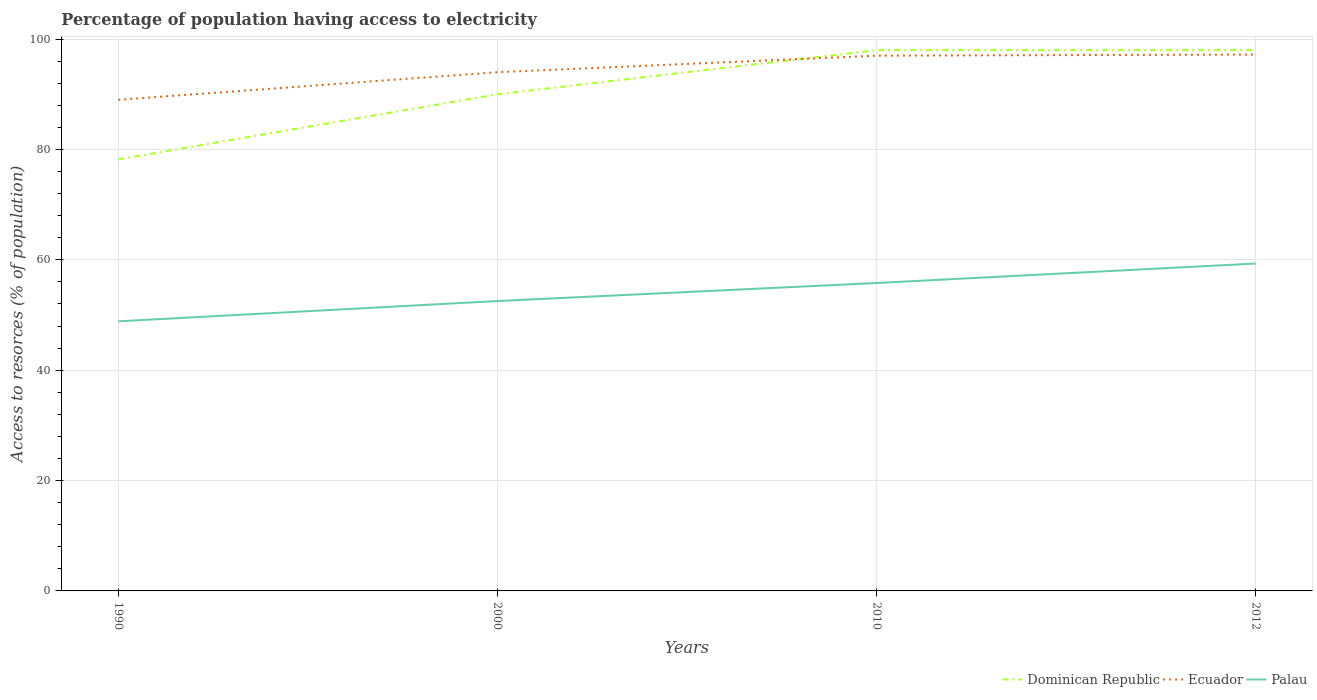Does the line corresponding to Palau intersect with the line corresponding to Dominican Republic?
Your response must be concise. No. Across all years, what is the maximum percentage of population having access to electricity in Palau?
Your response must be concise. 48.86. In which year was the percentage of population having access to electricity in Palau maximum?
Keep it short and to the point. 1990. What is the total percentage of population having access to electricity in Ecuador in the graph?
Keep it short and to the point. -0.2. What is the difference between the highest and the second highest percentage of population having access to electricity in Palau?
Your response must be concise. 10.47. Is the percentage of population having access to electricity in Dominican Republic strictly greater than the percentage of population having access to electricity in Palau over the years?
Keep it short and to the point. No. How many legend labels are there?
Ensure brevity in your answer.  3. How are the legend labels stacked?
Provide a short and direct response. Horizontal. What is the title of the graph?
Make the answer very short. Percentage of population having access to electricity. What is the label or title of the Y-axis?
Offer a very short reply. Access to resorces (% of population). What is the Access to resorces (% of population) of Dominican Republic in 1990?
Make the answer very short. 78.2. What is the Access to resorces (% of population) in Ecuador in 1990?
Your answer should be compact. 89. What is the Access to resorces (% of population) of Palau in 1990?
Give a very brief answer. 48.86. What is the Access to resorces (% of population) in Ecuador in 2000?
Provide a short and direct response. 94. What is the Access to resorces (% of population) of Palau in 2000?
Your response must be concise. 52.53. What is the Access to resorces (% of population) in Ecuador in 2010?
Provide a succinct answer. 97. What is the Access to resorces (% of population) in Palau in 2010?
Give a very brief answer. 55.8. What is the Access to resorces (% of population) in Ecuador in 2012?
Give a very brief answer. 97.2. What is the Access to resorces (% of population) of Palau in 2012?
Offer a very short reply. 59.33. Across all years, what is the maximum Access to resorces (% of population) in Ecuador?
Give a very brief answer. 97.2. Across all years, what is the maximum Access to resorces (% of population) in Palau?
Keep it short and to the point. 59.33. Across all years, what is the minimum Access to resorces (% of population) of Dominican Republic?
Give a very brief answer. 78.2. Across all years, what is the minimum Access to resorces (% of population) in Ecuador?
Provide a short and direct response. 89. Across all years, what is the minimum Access to resorces (% of population) of Palau?
Ensure brevity in your answer.  48.86. What is the total Access to resorces (% of population) in Dominican Republic in the graph?
Your answer should be very brief. 364.2. What is the total Access to resorces (% of population) of Ecuador in the graph?
Provide a short and direct response. 377.2. What is the total Access to resorces (% of population) in Palau in the graph?
Give a very brief answer. 216.52. What is the difference between the Access to resorces (% of population) of Dominican Republic in 1990 and that in 2000?
Provide a succinct answer. -11.8. What is the difference between the Access to resorces (% of population) in Ecuador in 1990 and that in 2000?
Your response must be concise. -5. What is the difference between the Access to resorces (% of population) in Palau in 1990 and that in 2000?
Keep it short and to the point. -3.67. What is the difference between the Access to resorces (% of population) in Dominican Republic in 1990 and that in 2010?
Offer a terse response. -19.8. What is the difference between the Access to resorces (% of population) in Palau in 1990 and that in 2010?
Keep it short and to the point. -6.94. What is the difference between the Access to resorces (% of population) of Dominican Republic in 1990 and that in 2012?
Your response must be concise. -19.8. What is the difference between the Access to resorces (% of population) in Ecuador in 1990 and that in 2012?
Provide a short and direct response. -8.2. What is the difference between the Access to resorces (% of population) of Palau in 1990 and that in 2012?
Provide a succinct answer. -10.47. What is the difference between the Access to resorces (% of population) of Ecuador in 2000 and that in 2010?
Provide a succinct answer. -3. What is the difference between the Access to resorces (% of population) of Palau in 2000 and that in 2010?
Your answer should be very brief. -3.27. What is the difference between the Access to resorces (% of population) in Dominican Republic in 2000 and that in 2012?
Your answer should be compact. -8. What is the difference between the Access to resorces (% of population) of Ecuador in 2000 and that in 2012?
Ensure brevity in your answer.  -3.2. What is the difference between the Access to resorces (% of population) in Palau in 2000 and that in 2012?
Your answer should be compact. -6.8. What is the difference between the Access to resorces (% of population) of Dominican Republic in 2010 and that in 2012?
Make the answer very short. 0. What is the difference between the Access to resorces (% of population) in Ecuador in 2010 and that in 2012?
Give a very brief answer. -0.2. What is the difference between the Access to resorces (% of population) in Palau in 2010 and that in 2012?
Give a very brief answer. -3.53. What is the difference between the Access to resorces (% of population) of Dominican Republic in 1990 and the Access to resorces (% of population) of Ecuador in 2000?
Offer a very short reply. -15.8. What is the difference between the Access to resorces (% of population) of Dominican Republic in 1990 and the Access to resorces (% of population) of Palau in 2000?
Give a very brief answer. 25.67. What is the difference between the Access to resorces (% of population) of Ecuador in 1990 and the Access to resorces (% of population) of Palau in 2000?
Your answer should be compact. 36.47. What is the difference between the Access to resorces (% of population) of Dominican Republic in 1990 and the Access to resorces (% of population) of Ecuador in 2010?
Ensure brevity in your answer.  -18.8. What is the difference between the Access to resorces (% of population) in Dominican Republic in 1990 and the Access to resorces (% of population) in Palau in 2010?
Provide a succinct answer. 22.4. What is the difference between the Access to resorces (% of population) of Ecuador in 1990 and the Access to resorces (% of population) of Palau in 2010?
Offer a terse response. 33.2. What is the difference between the Access to resorces (% of population) in Dominican Republic in 1990 and the Access to resorces (% of population) in Palau in 2012?
Keep it short and to the point. 18.87. What is the difference between the Access to resorces (% of population) of Ecuador in 1990 and the Access to resorces (% of population) of Palau in 2012?
Make the answer very short. 29.67. What is the difference between the Access to resorces (% of population) of Dominican Republic in 2000 and the Access to resorces (% of population) of Ecuador in 2010?
Provide a short and direct response. -7. What is the difference between the Access to resorces (% of population) of Dominican Republic in 2000 and the Access to resorces (% of population) of Palau in 2010?
Your answer should be compact. 34.2. What is the difference between the Access to resorces (% of population) of Ecuador in 2000 and the Access to resorces (% of population) of Palau in 2010?
Your response must be concise. 38.2. What is the difference between the Access to resorces (% of population) of Dominican Republic in 2000 and the Access to resorces (% of population) of Palau in 2012?
Provide a succinct answer. 30.67. What is the difference between the Access to resorces (% of population) of Ecuador in 2000 and the Access to resorces (% of population) of Palau in 2012?
Offer a terse response. 34.67. What is the difference between the Access to resorces (% of population) in Dominican Republic in 2010 and the Access to resorces (% of population) in Ecuador in 2012?
Keep it short and to the point. 0.8. What is the difference between the Access to resorces (% of population) of Dominican Republic in 2010 and the Access to resorces (% of population) of Palau in 2012?
Provide a succinct answer. 38.67. What is the difference between the Access to resorces (% of population) in Ecuador in 2010 and the Access to resorces (% of population) in Palau in 2012?
Provide a short and direct response. 37.67. What is the average Access to resorces (% of population) in Dominican Republic per year?
Provide a short and direct response. 91.05. What is the average Access to resorces (% of population) in Ecuador per year?
Your answer should be very brief. 94.3. What is the average Access to resorces (% of population) of Palau per year?
Make the answer very short. 54.13. In the year 1990, what is the difference between the Access to resorces (% of population) of Dominican Republic and Access to resorces (% of population) of Ecuador?
Offer a terse response. -10.8. In the year 1990, what is the difference between the Access to resorces (% of population) of Dominican Republic and Access to resorces (% of population) of Palau?
Ensure brevity in your answer.  29.34. In the year 1990, what is the difference between the Access to resorces (% of population) in Ecuador and Access to resorces (% of population) in Palau?
Keep it short and to the point. 40.14. In the year 2000, what is the difference between the Access to resorces (% of population) in Dominican Republic and Access to resorces (% of population) in Palau?
Ensure brevity in your answer.  37.47. In the year 2000, what is the difference between the Access to resorces (% of population) in Ecuador and Access to resorces (% of population) in Palau?
Offer a terse response. 41.47. In the year 2010, what is the difference between the Access to resorces (% of population) of Dominican Republic and Access to resorces (% of population) of Palau?
Your answer should be very brief. 42.2. In the year 2010, what is the difference between the Access to resorces (% of population) of Ecuador and Access to resorces (% of population) of Palau?
Offer a terse response. 41.2. In the year 2012, what is the difference between the Access to resorces (% of population) of Dominican Republic and Access to resorces (% of population) of Palau?
Your answer should be very brief. 38.67. In the year 2012, what is the difference between the Access to resorces (% of population) of Ecuador and Access to resorces (% of population) of Palau?
Ensure brevity in your answer.  37.87. What is the ratio of the Access to resorces (% of population) in Dominican Republic in 1990 to that in 2000?
Make the answer very short. 0.87. What is the ratio of the Access to resorces (% of population) in Ecuador in 1990 to that in 2000?
Offer a terse response. 0.95. What is the ratio of the Access to resorces (% of population) in Palau in 1990 to that in 2000?
Your answer should be very brief. 0.93. What is the ratio of the Access to resorces (% of population) in Dominican Republic in 1990 to that in 2010?
Keep it short and to the point. 0.8. What is the ratio of the Access to resorces (% of population) of Ecuador in 1990 to that in 2010?
Provide a succinct answer. 0.92. What is the ratio of the Access to resorces (% of population) in Palau in 1990 to that in 2010?
Provide a succinct answer. 0.88. What is the ratio of the Access to resorces (% of population) in Dominican Republic in 1990 to that in 2012?
Your answer should be compact. 0.8. What is the ratio of the Access to resorces (% of population) in Ecuador in 1990 to that in 2012?
Your answer should be very brief. 0.92. What is the ratio of the Access to resorces (% of population) in Palau in 1990 to that in 2012?
Offer a terse response. 0.82. What is the ratio of the Access to resorces (% of population) in Dominican Republic in 2000 to that in 2010?
Your answer should be very brief. 0.92. What is the ratio of the Access to resorces (% of population) in Ecuador in 2000 to that in 2010?
Provide a succinct answer. 0.97. What is the ratio of the Access to resorces (% of population) in Palau in 2000 to that in 2010?
Provide a short and direct response. 0.94. What is the ratio of the Access to resorces (% of population) of Dominican Republic in 2000 to that in 2012?
Offer a terse response. 0.92. What is the ratio of the Access to resorces (% of population) in Ecuador in 2000 to that in 2012?
Provide a short and direct response. 0.97. What is the ratio of the Access to resorces (% of population) in Palau in 2000 to that in 2012?
Keep it short and to the point. 0.89. What is the ratio of the Access to resorces (% of population) of Dominican Republic in 2010 to that in 2012?
Offer a terse response. 1. What is the ratio of the Access to resorces (% of population) in Palau in 2010 to that in 2012?
Give a very brief answer. 0.94. What is the difference between the highest and the second highest Access to resorces (% of population) in Ecuador?
Make the answer very short. 0.2. What is the difference between the highest and the second highest Access to resorces (% of population) of Palau?
Keep it short and to the point. 3.53. What is the difference between the highest and the lowest Access to resorces (% of population) in Dominican Republic?
Your response must be concise. 19.8. What is the difference between the highest and the lowest Access to resorces (% of population) of Ecuador?
Make the answer very short. 8.2. What is the difference between the highest and the lowest Access to resorces (% of population) in Palau?
Offer a terse response. 10.47. 